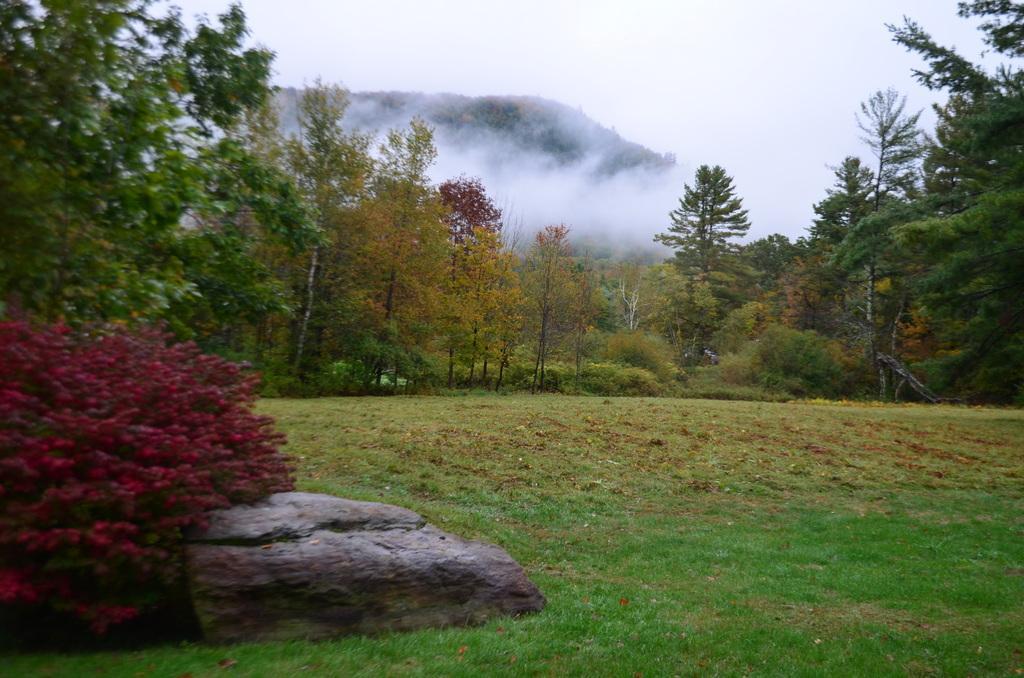Could you give a brief overview of what you see in this image? In this image we can see a tall trees of green color and yellow color and a group of hills with grassy land. 